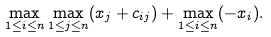<formula> <loc_0><loc_0><loc_500><loc_500>& & & \max _ { 1 \leq i \leq n } \max _ { 1 \leq j \leq n } ( x _ { j } + c _ { i j } ) + \max _ { 1 \leq i \leq n } ( - x _ { i } ) .</formula> 